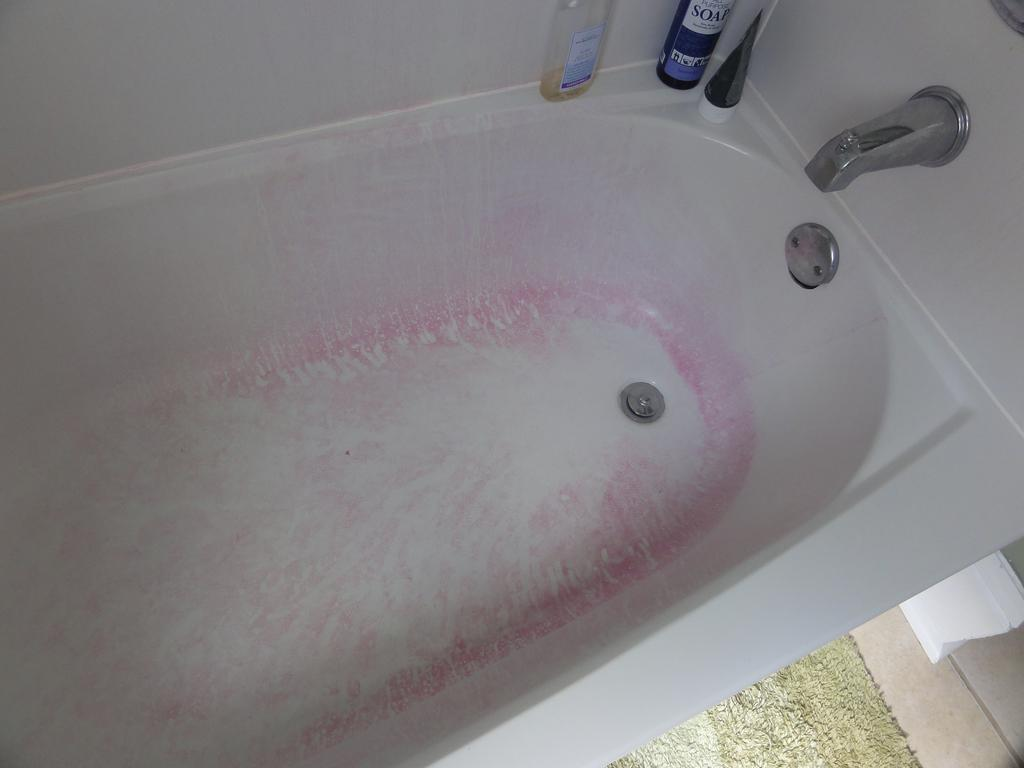What is the main object in the image? There is a bathtub in the image. What is attached to the bathtub? There is a tap on the bathtub. What items are related to bathing in the image? There are shampoo bottles in the image. What is on the floor at the bottom of the image? There is a mat on the floor at the bottom of the image. What is the purpose of the paper napkin in the image? The paper napkin in the image might be used for drying or cleaning. What type of breakfast is being prepared in the image? There is no breakfast being prepared in the image; it features a bathtub with related items. How can someone join the bathtub in the image? The image does not show any people or actions related to joining the bathtub; it only shows the bathtub and related items. 